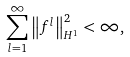<formula> <loc_0><loc_0><loc_500><loc_500>\sum _ { l = 1 } ^ { \infty } \left \| f ^ { l } \right \| _ { H ^ { 1 } } ^ { 2 } < \infty ,</formula> 